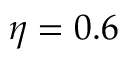<formula> <loc_0><loc_0><loc_500><loc_500>\eta = 0 . 6</formula> 